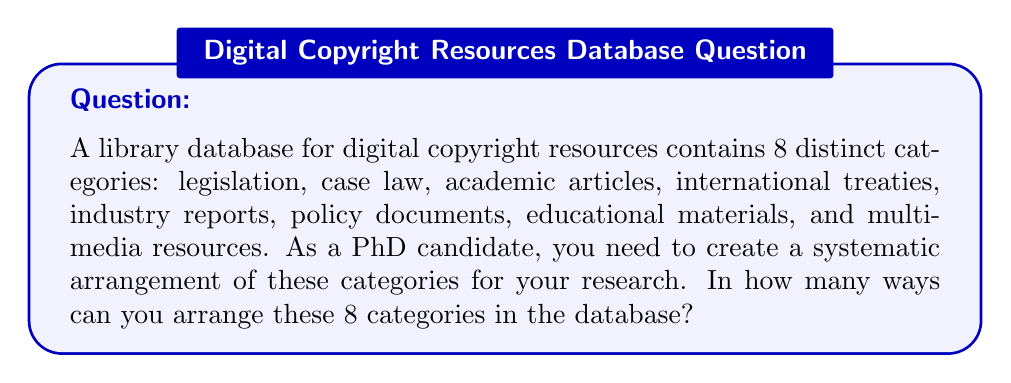Help me with this question. To solve this problem, we need to consider the following steps:

1) We have 8 distinct categories that need to be arranged.
2) Each category can be placed in any position, and the order matters.
3) This scenario represents a permutation of 8 distinct objects.

The formula for permutations of n distinct objects is:

$$P(n) = n!$$

Where $n!$ (n factorial) is the product of all positive integers less than or equal to n.

In this case, $n = 8$, so we calculate:

$$P(8) = 8!$$
$$= 8 \times 7 \times 6 \times 5 \times 4 \times 3 \times 2 \times 1$$
$$= 40,320$$

Therefore, there are 40,320 possible ways to arrange the 8 categories of digital copyright resources in the library database.
Answer: $40,320$ 